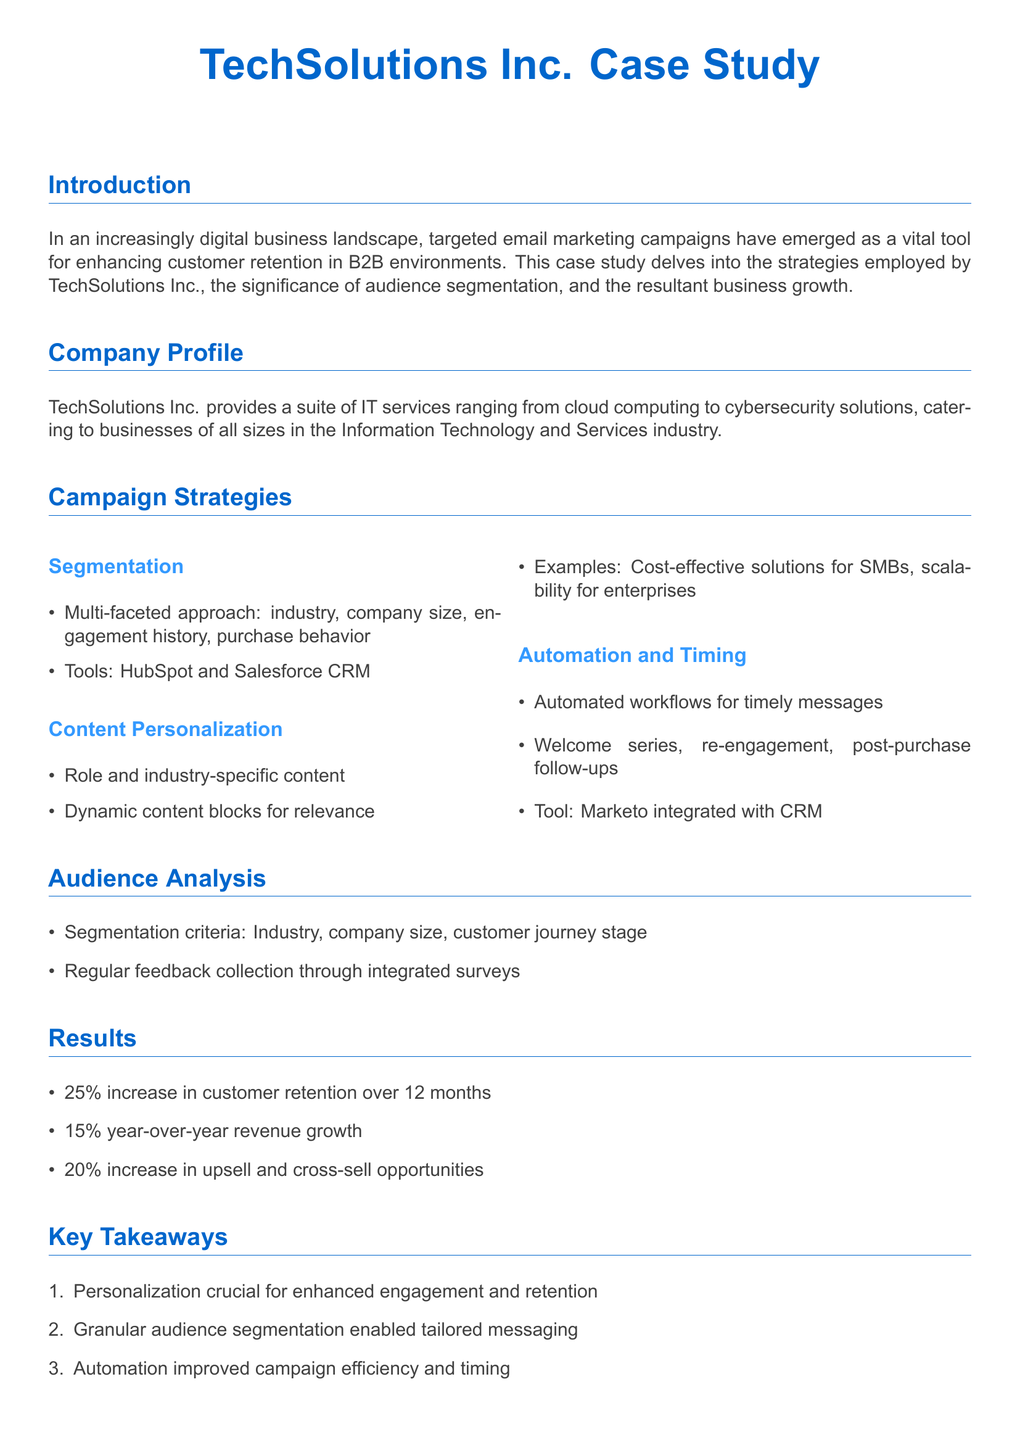What is the name of the company in the case study? The first section of the document introduces TechSolutions Inc. as the company being studied.
Answer: TechSolutions Inc What percentage increase in customer retention was reported? The results section states there was a 25% increase in customer retention over 12 months.
Answer: 25% Which tool was used for automation? The document mentions Marketo as the tool integrated with CRM for automation.
Answer: Marketo What was the year-over-year revenue growth percentage? According to the results section, the year-over-year revenue growth was 15%.
Answer: 15% What is a key takeaway regarding audience segmentation? The document emphasizes that granular audience segmentation enabled tailored messaging.
Answer: Tailored messaging What types of content were personalized in the campaigns? The campaign strategies section highlights that role and industry-specific content was used for personalization.
Answer: Role and industry-specific content How many months did the analysis cover? The document states that the analysis of customer retention increase covered a period of 12 months.
Answer: 12 months What approach did the segmentation utilize? The segmentation employed a multi-faceted approach considering various criteria like industry and company size.
Answer: Multi-faceted approach What was one of the engagement strategies used in the email campaigns? The case study mentions post-purchase follow-ups as a part of their automated workflow.
Answer: Post-purchase follow-ups 